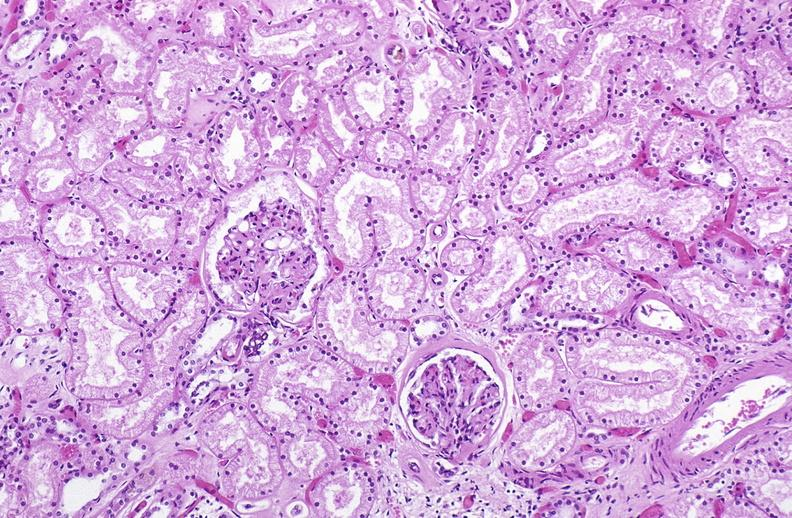does gross show atn acute tubular necrosis?
Answer the question using a single word or phrase. No 